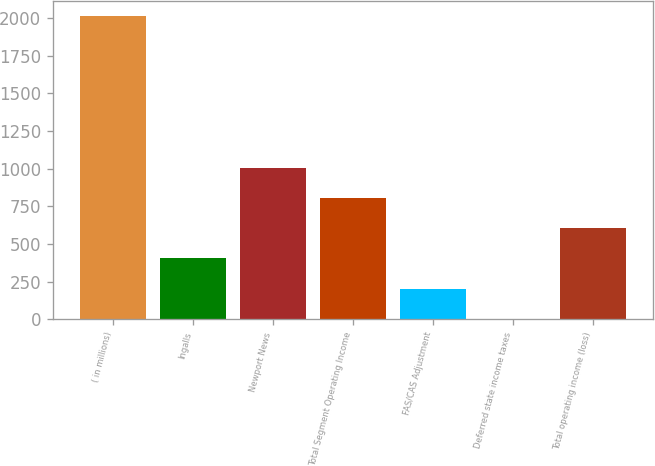<chart> <loc_0><loc_0><loc_500><loc_500><bar_chart><fcel>( in millions)<fcel>Ingalls<fcel>Newport News<fcel>Total Segment Operating Income<fcel>FAS/CAS Adjustment<fcel>Deferred state income taxes<fcel>Total operating income (loss)<nl><fcel>2010<fcel>404.4<fcel>1006.5<fcel>805.8<fcel>203.7<fcel>3<fcel>605.1<nl></chart> 